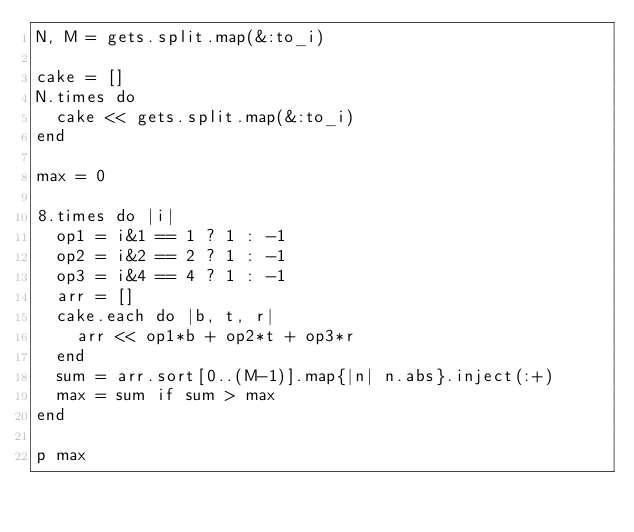Convert code to text. <code><loc_0><loc_0><loc_500><loc_500><_Ruby_>N, M = gets.split.map(&:to_i)

cake = []
N.times do
  cake << gets.split.map(&:to_i)
end

max = 0

8.times do |i|
  op1 = i&1 == 1 ? 1 : -1
  op2 = i&2 == 2 ? 1 : -1
  op3 = i&4 == 4 ? 1 : -1
  arr = []
  cake.each do |b, t, r|
    arr << op1*b + op2*t + op3*r
  end
  sum = arr.sort[0..(M-1)].map{|n| n.abs}.inject(:+)
  max = sum if sum > max
end

p max</code> 